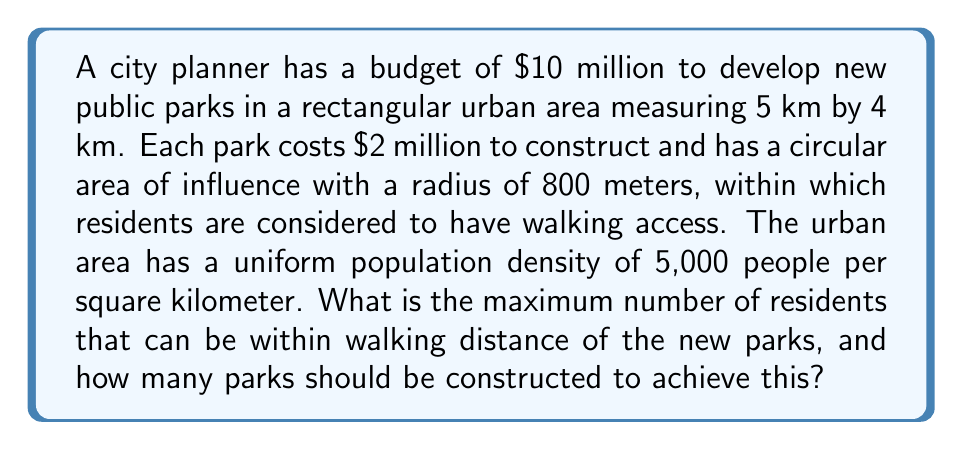Could you help me with this problem? Let's approach this step-by-step:

1) First, we need to calculate how many parks can be constructed with the given budget:
   $$\text{Number of parks} = \frac{\text{Total budget}}{\text{Cost per park}} = \frac{\$10,000,000}{\$2,000,000} = 5\text{ parks}$$

2) Each park has a circular area of influence with a radius of 800 meters. The area of this circle is:
   $$A = \pi r^2 = \pi \cdot (0.8\text{ km})^2 \approx 2.01\text{ km}^2$$

3) The total urban area is:
   $$5\text{ km} \times 4\text{ km} = 20\text{ km}^2$$

4) To maximize the number of residents within walking distance, we need to maximize the coverage area of the parks. The ideal arrangement would be to place the parks so that their areas of influence do not overlap and are completely within the urban area.

5) The maximum number of non-overlapping circles that can fit in the rectangle is 5, which coincides with our budget constraint. This can be visualized as follows:

   [asy]
   size(200);
   draw((0,0)--(5,0)--(5,4)--(0,4)--cycle);
   draw(circle((1,1),0.8));
   draw(circle((3,1),0.8));
   draw(circle((1,3),0.8));
   draw(circle((3,3),0.8));
   draw(circle((4.2,2),0.8));
   [/asy]

6) The total area covered by the parks is:
   $$5 \cdot 2.01\text{ km}^2 = 10.05\text{ km}^2$$

7) Given the uniform population density, the number of residents within walking distance is:
   $$10.05\text{ km}^2 \cdot 5,000\text{ people/km}^2 = 50,250\text{ people}$$

Therefore, the maximum number of residents within walking distance is 50,250, achieved by constructing 5 parks.
Answer: The maximum number of residents within walking distance of the new parks is 50,250, achieved by constructing 5 parks. 